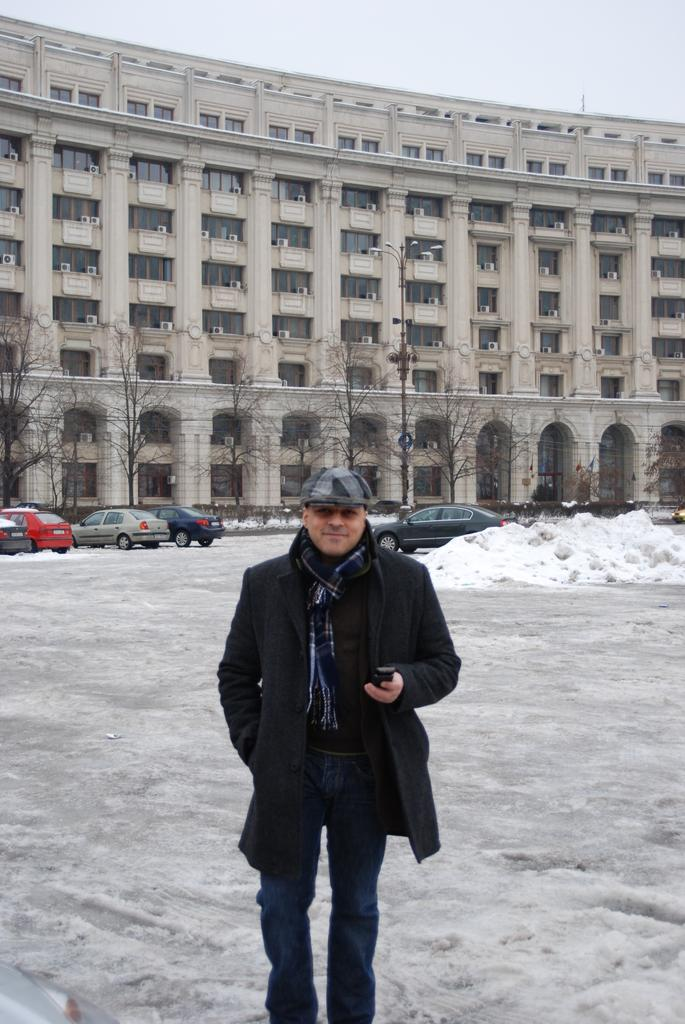What is the man in the image doing? The man is smiling in the image. What is the man holding in the image? The man is holding an object in the image. What can be seen in the background of the image? There is snow, trees, vehicles, at least one building, walls, glass objects, and the sky visible in the background of the image. How does the man rub his hands together in the image? The man is not rubbing his hands together in the image; he is simply smiling and holding an object. 